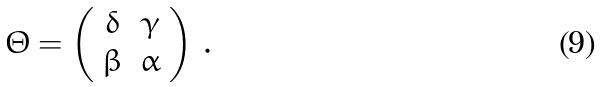<formula> <loc_0><loc_0><loc_500><loc_500>\Theta = \left ( \begin{array} { c c } \delta & \gamma \\ \beta & \alpha \\ \end{array} \right ) \, .</formula> 